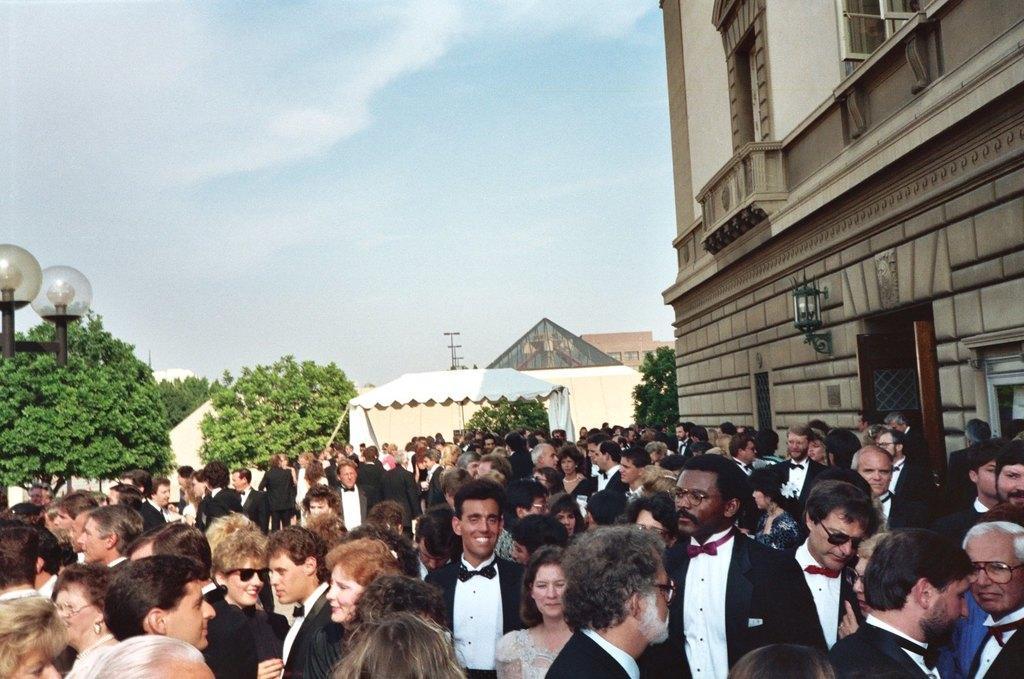Describe this image in one or two sentences. In this picture I can see number of people who are standing in front and on the right side of this picture I can see few buildings. In the background I can see the trees, 2 lights and the sky. 